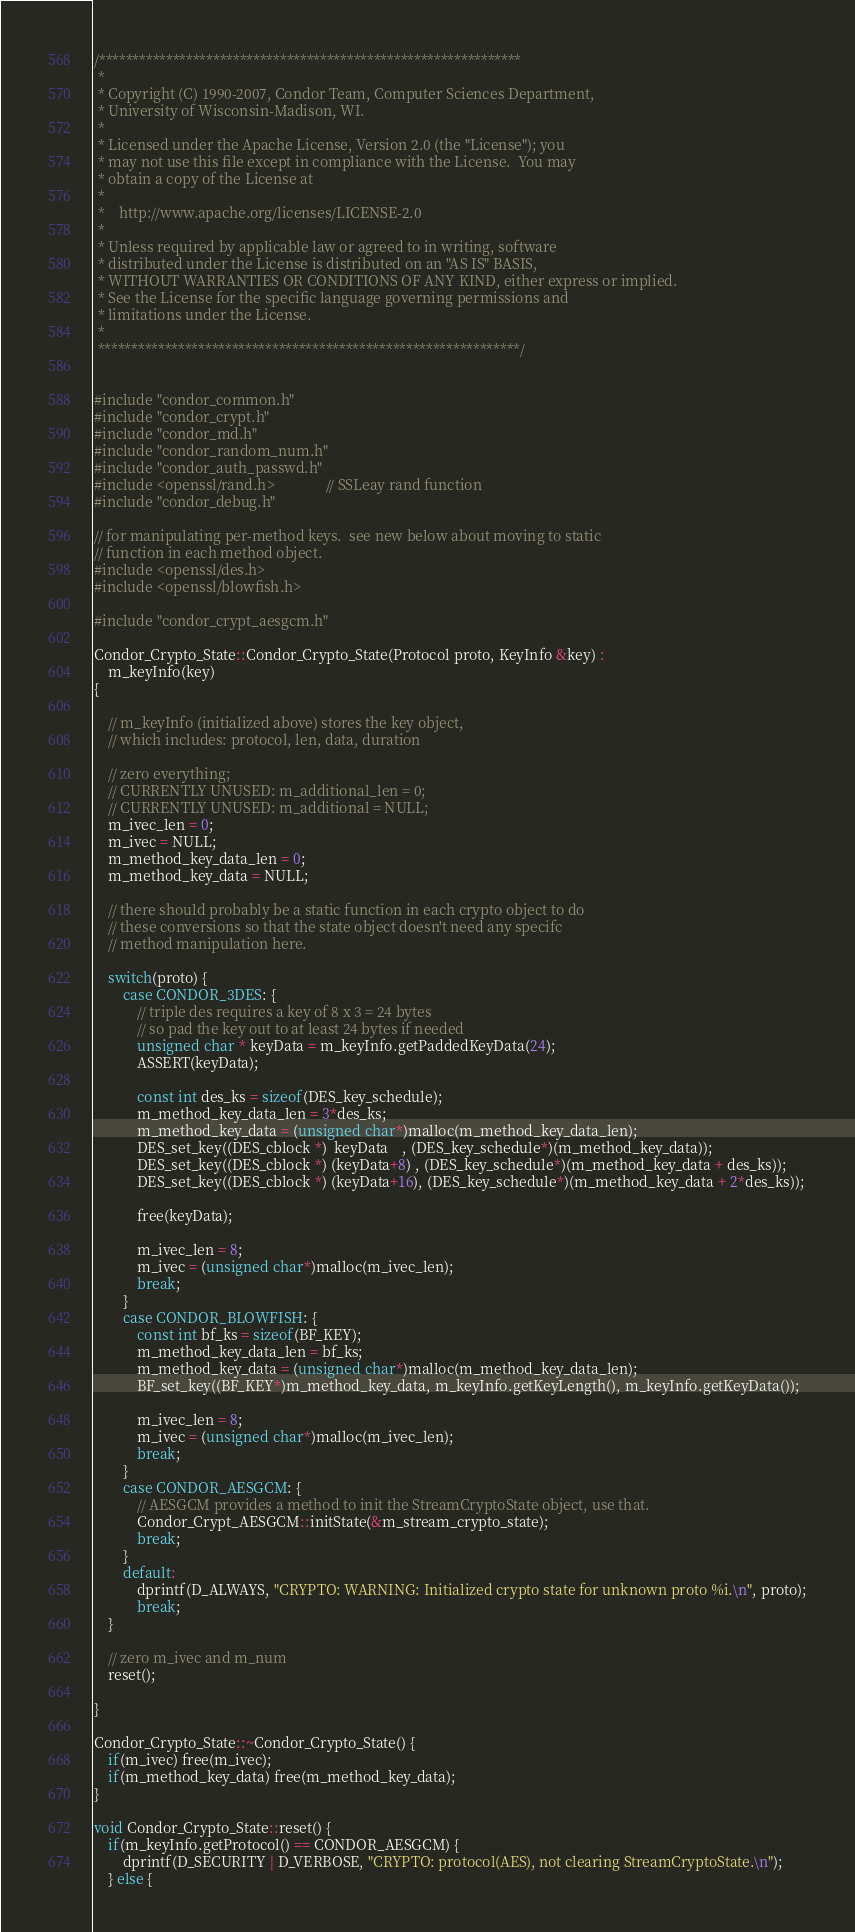Convert code to text. <code><loc_0><loc_0><loc_500><loc_500><_C++_>/***************************************************************
 *
 * Copyright (C) 1990-2007, Condor Team, Computer Sciences Department,
 * University of Wisconsin-Madison, WI.
 * 
 * Licensed under the Apache License, Version 2.0 (the "License"); you
 * may not use this file except in compliance with the License.  You may
 * obtain a copy of the License at
 * 
 *    http://www.apache.org/licenses/LICENSE-2.0
 * 
 * Unless required by applicable law or agreed to in writing, software
 * distributed under the License is distributed on an "AS IS" BASIS,
 * WITHOUT WARRANTIES OR CONDITIONS OF ANY KIND, either express or implied.
 * See the License for the specific language governing permissions and
 * limitations under the License.
 *
 ***************************************************************/


#include "condor_common.h"
#include "condor_crypt.h"
#include "condor_md.h"
#include "condor_random_num.h"
#include "condor_auth_passwd.h"
#include <openssl/rand.h>              // SSLeay rand function
#include "condor_debug.h"

// for manipulating per-method keys.  see new below about moving to static
// function in each method object.
#include <openssl/des.h>
#include <openssl/blowfish.h>

#include "condor_crypt_aesgcm.h"

Condor_Crypto_State::Condor_Crypto_State(Protocol proto, KeyInfo &key) :
    m_keyInfo(key)
{

    // m_keyInfo (initialized above) stores the key object,
    // which includes: protocol, len, data, duration

    // zero everything;
    // CURRENTLY UNUSED: m_additional_len = 0;
    // CURRENTLY UNUSED: m_additional = NULL;
    m_ivec_len = 0;
    m_ivec = NULL;
    m_method_key_data_len = 0;
    m_method_key_data = NULL;

    // there should probably be a static function in each crypto object to do
    // these conversions so that the state object doesn't need any specifc
    // method manipulation here.

    switch(proto) {
        case CONDOR_3DES: {
            // triple des requires a key of 8 x 3 = 24 bytes
            // so pad the key out to at least 24 bytes if needed
            unsigned char * keyData = m_keyInfo.getPaddedKeyData(24);
            ASSERT(keyData);

            const int des_ks = sizeof(DES_key_schedule);
            m_method_key_data_len = 3*des_ks;
            m_method_key_data = (unsigned char*)malloc(m_method_key_data_len);
            DES_set_key((DES_cblock *)  keyData    , (DES_key_schedule*)(m_method_key_data));
            DES_set_key((DES_cblock *) (keyData+8) , (DES_key_schedule*)(m_method_key_data + des_ks));
            DES_set_key((DES_cblock *) (keyData+16), (DES_key_schedule*)(m_method_key_data + 2*des_ks));

            free(keyData);

            m_ivec_len = 8;
            m_ivec = (unsigned char*)malloc(m_ivec_len);
            break;
        }
        case CONDOR_BLOWFISH: {
            const int bf_ks = sizeof(BF_KEY);
            m_method_key_data_len = bf_ks;
            m_method_key_data = (unsigned char*)malloc(m_method_key_data_len);
            BF_set_key((BF_KEY*)m_method_key_data, m_keyInfo.getKeyLength(), m_keyInfo.getKeyData());

            m_ivec_len = 8;
            m_ivec = (unsigned char*)malloc(m_ivec_len);
            break;
        }
        case CONDOR_AESGCM: {
            // AESGCM provides a method to init the StreamCryptoState object, use that.
            Condor_Crypt_AESGCM::initState(&m_stream_crypto_state);
            break;
        }
        default:
            dprintf(D_ALWAYS, "CRYPTO: WARNING: Initialized crypto state for unknown proto %i.\n", proto);
            break;
    }

    // zero m_ivec and m_num
    reset();

}

Condor_Crypto_State::~Condor_Crypto_State() {
    if(m_ivec) free(m_ivec);
    if(m_method_key_data) free(m_method_key_data);
}

void Condor_Crypto_State::reset() {
    if(m_keyInfo.getProtocol() == CONDOR_AESGCM) {
        dprintf(D_SECURITY | D_VERBOSE, "CRYPTO: protocol(AES), not clearing StreamCryptoState.\n");
    } else {</code> 